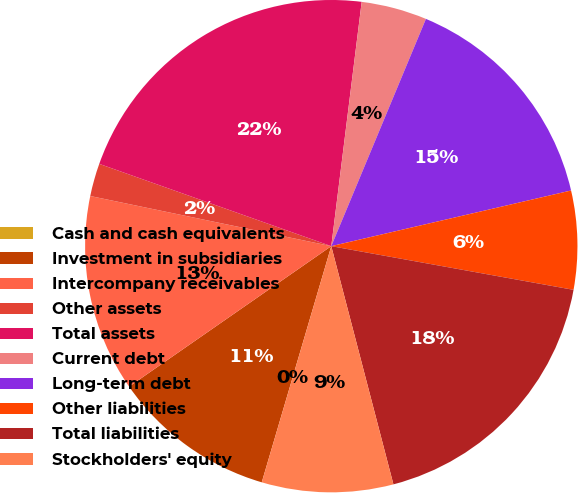Convert chart. <chart><loc_0><loc_0><loc_500><loc_500><pie_chart><fcel>Cash and cash equivalents<fcel>Investment in subsidiaries<fcel>Intercompany receivables<fcel>Other assets<fcel>Total assets<fcel>Current debt<fcel>Long-term debt<fcel>Other liabilities<fcel>Total liabilities<fcel>Stockholders' equity<nl><fcel>0.0%<fcel>10.78%<fcel>12.93%<fcel>2.16%<fcel>21.55%<fcel>4.31%<fcel>15.09%<fcel>6.47%<fcel>18.1%<fcel>8.62%<nl></chart> 